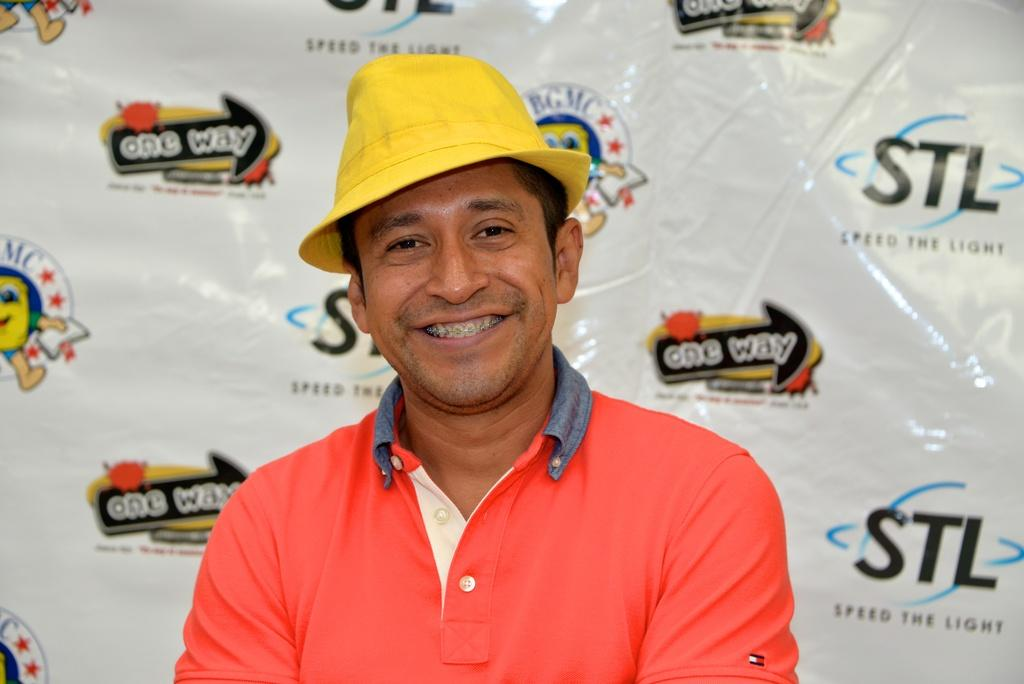Who is present in the image? There is a person in the image. What is the person wearing on their upper body? The person is wearing a T-shirt. What is the person's facial expression in the image? The person is smiling. What type of headwear is the person wearing? The person is wearing a yellow hat. What can be seen in the background of the image? There is a poster in the background of the image. What type of verse is being recited by the judge in the image? There is no judge or verse present in the image; it features a person wearing a T-shirt, a yellow hat, and a smiling expression. 